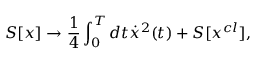Convert formula to latex. <formula><loc_0><loc_0><loc_500><loc_500>S [ x ] \to \frac { 1 } { 4 } \int _ { 0 } ^ { T } { d t \dot { x } ^ { 2 } } ( t ) + S [ x ^ { c l } ] ,</formula> 